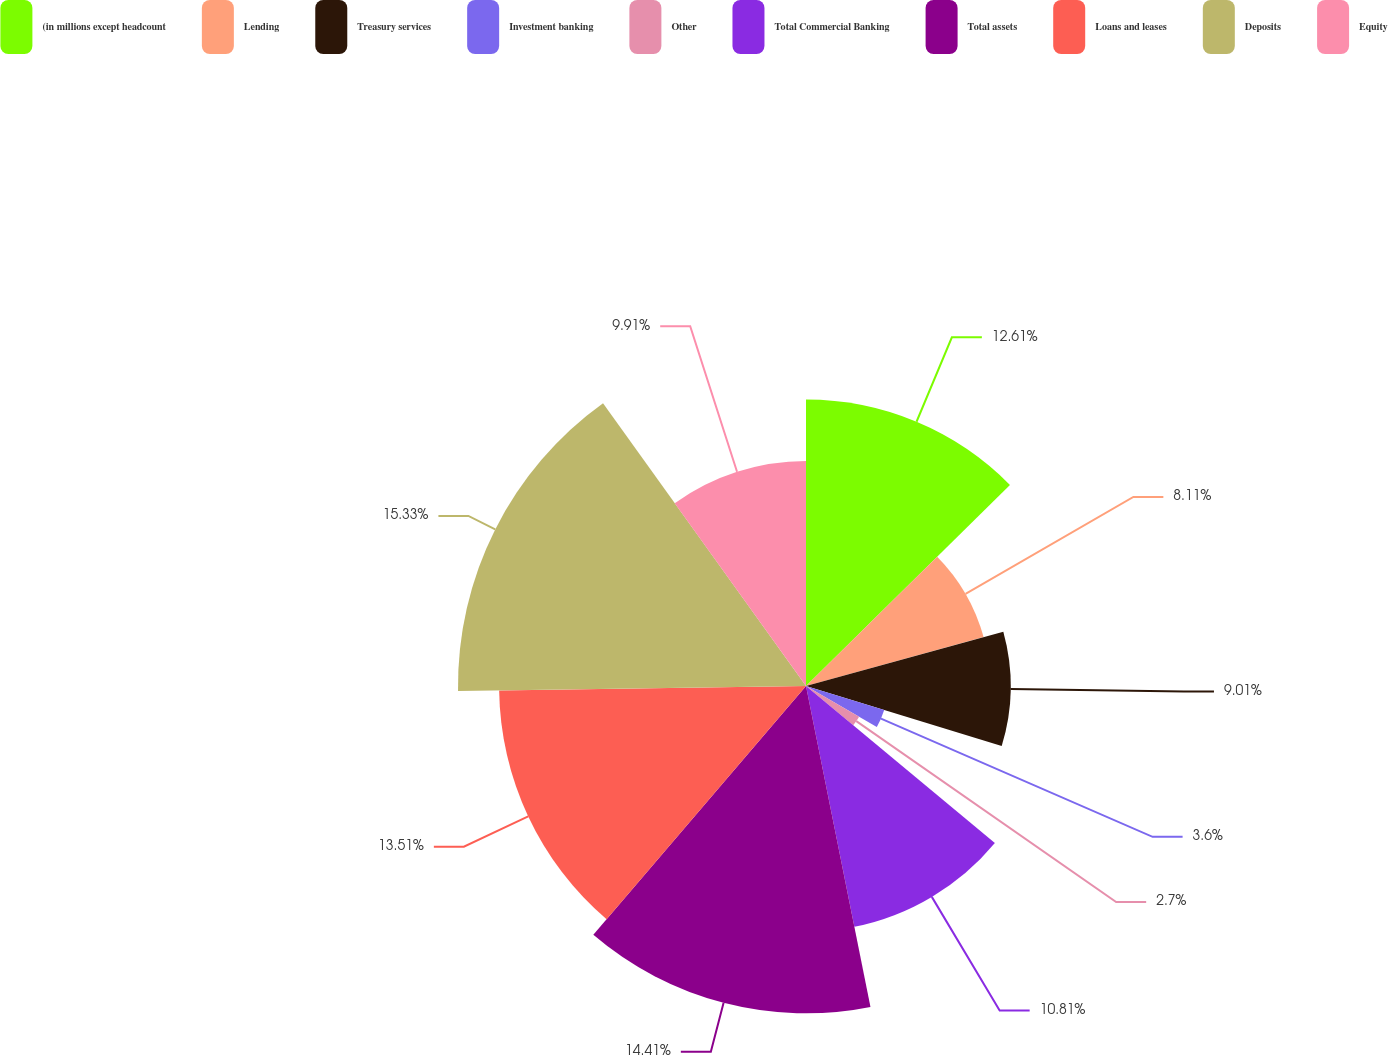Convert chart. <chart><loc_0><loc_0><loc_500><loc_500><pie_chart><fcel>(in millions except headcount<fcel>Lending<fcel>Treasury services<fcel>Investment banking<fcel>Other<fcel>Total Commercial Banking<fcel>Total assets<fcel>Loans and leases<fcel>Deposits<fcel>Equity<nl><fcel>12.61%<fcel>8.11%<fcel>9.01%<fcel>3.6%<fcel>2.7%<fcel>10.81%<fcel>14.41%<fcel>13.51%<fcel>15.32%<fcel>9.91%<nl></chart> 